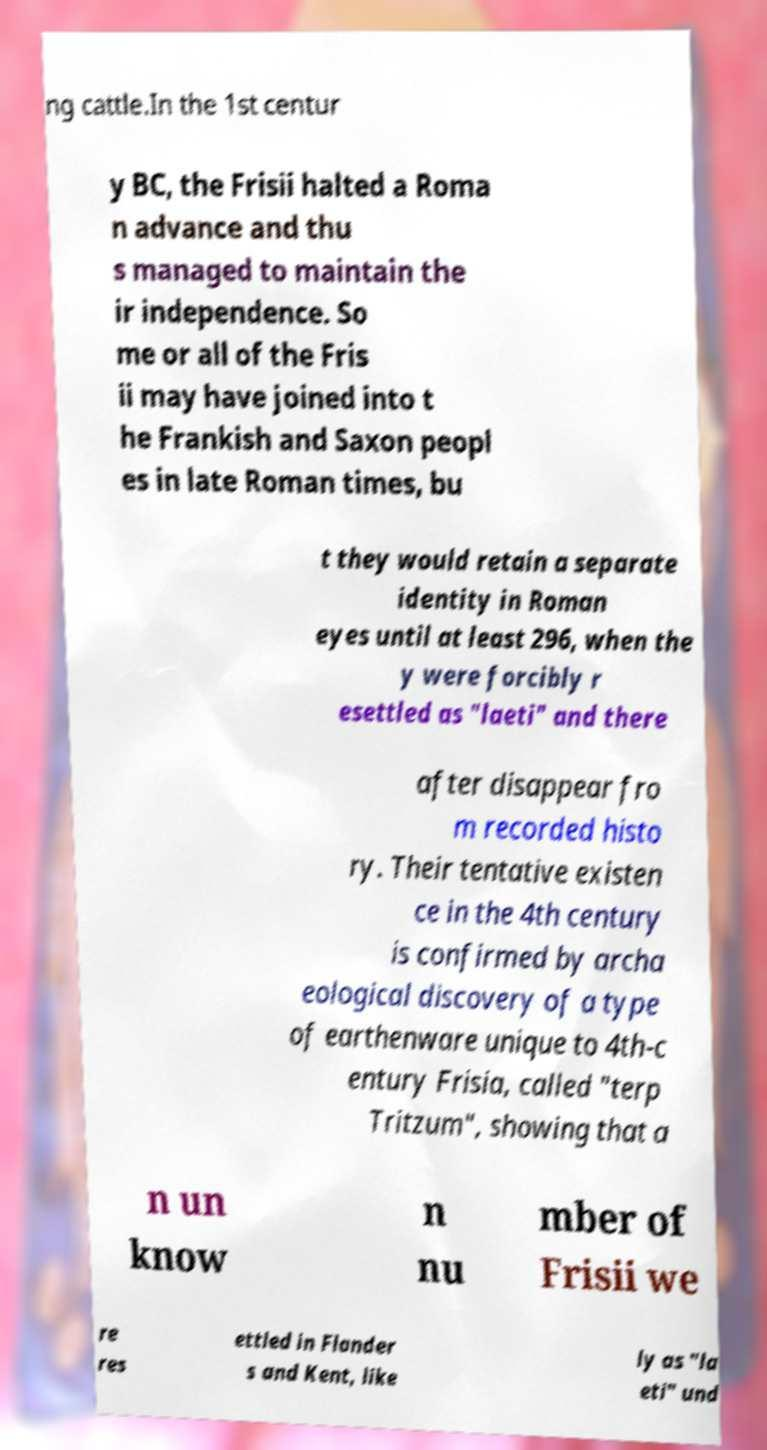For documentation purposes, I need the text within this image transcribed. Could you provide that? ng cattle.In the 1st centur y BC, the Frisii halted a Roma n advance and thu s managed to maintain the ir independence. So me or all of the Fris ii may have joined into t he Frankish and Saxon peopl es in late Roman times, bu t they would retain a separate identity in Roman eyes until at least 296, when the y were forcibly r esettled as "laeti" and there after disappear fro m recorded histo ry. Their tentative existen ce in the 4th century is confirmed by archa eological discovery of a type of earthenware unique to 4th-c entury Frisia, called "terp Tritzum", showing that a n un know n nu mber of Frisii we re res ettled in Flander s and Kent, like ly as "la eti" und 